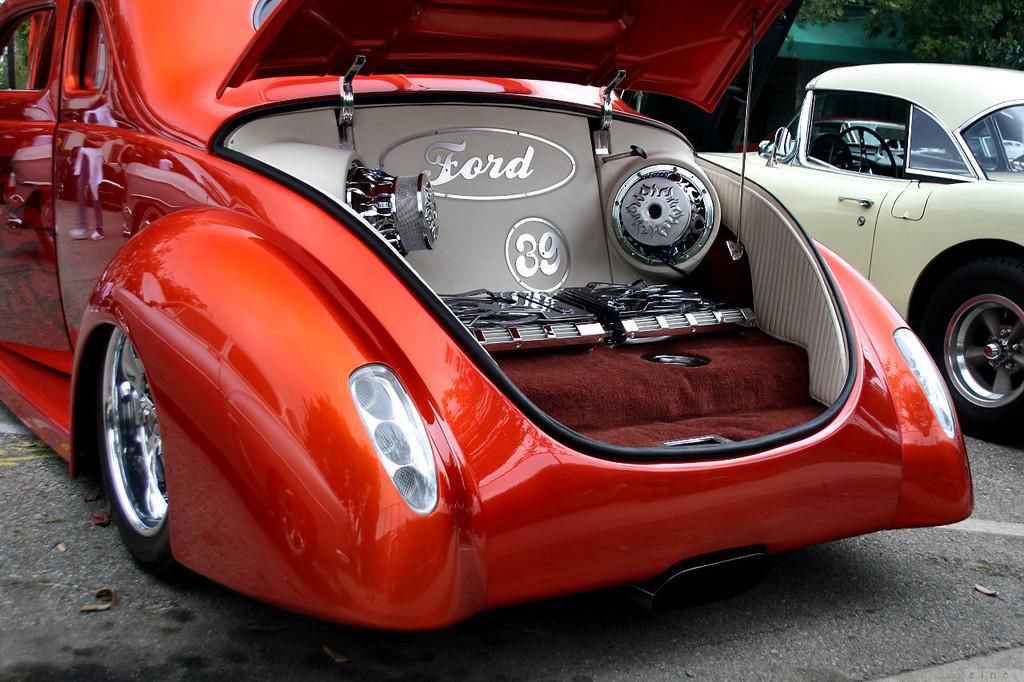What make of car?
Keep it short and to the point. Ford. 